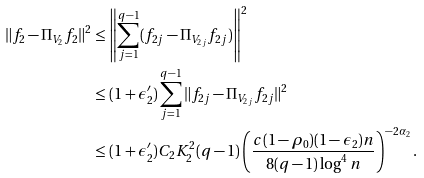Convert formula to latex. <formula><loc_0><loc_0><loc_500><loc_500>\| f _ { 2 } - \Pi _ { V _ { 2 } } f _ { 2 } \| ^ { 2 } & \leq \left \| \sum _ { j = 1 } ^ { q - 1 } ( f _ { 2 j } - \Pi _ { V _ { 2 j } } f _ { 2 j } ) \right \| ^ { 2 } \\ & \leq ( 1 + \epsilon _ { 2 } ^ { \prime } ) \sum _ { j = 1 } ^ { q - 1 } \| f _ { 2 j } - \Pi _ { V _ { 2 j } } f _ { 2 j } \| ^ { 2 } \\ & \leq ( 1 + \epsilon _ { 2 } ^ { \prime } ) C _ { 2 } K _ { 2 } ^ { 2 } ( q - 1 ) \left ( \frac { c ( 1 - \rho _ { 0 } ) ( 1 - \epsilon _ { 2 } ) n } { 8 ( q - 1 ) \log ^ { 4 } n } \right ) ^ { - 2 \alpha _ { 2 } } .</formula> 